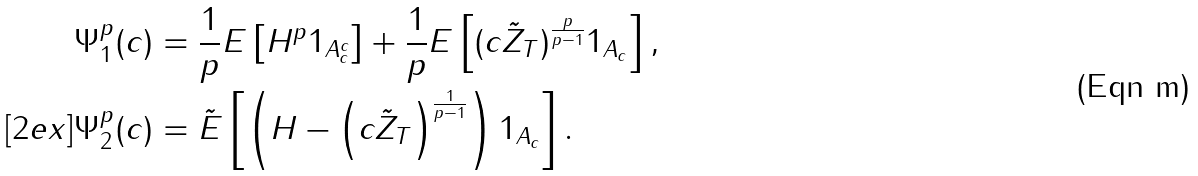Convert formula to latex. <formula><loc_0><loc_0><loc_500><loc_500>\Psi ^ { p } _ { 1 } ( c ) & = \frac { 1 } { p } E \left [ H ^ { p } 1 _ { A _ { c } ^ { c } } \right ] + \frac { 1 } { p } E \left [ ( c \tilde { Z } _ { T } ) ^ { \frac { p } { p - 1 } } 1 _ { A _ { c } } \right ] , \\ [ 2 e x ] \Psi ^ { p } _ { 2 } ( c ) & = \tilde { E } \left [ \left ( H - \left ( c \tilde { Z } _ { T } \right ) ^ { \frac { 1 } { p - 1 } } \right ) 1 _ { A _ { c } } \right ] .</formula> 